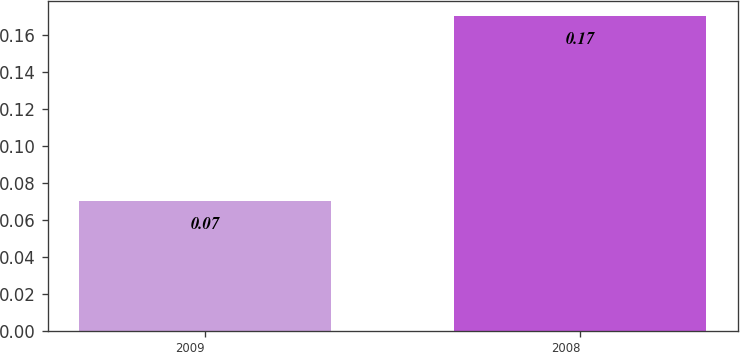Convert chart. <chart><loc_0><loc_0><loc_500><loc_500><bar_chart><fcel>2009<fcel>2008<nl><fcel>0.07<fcel>0.17<nl></chart> 